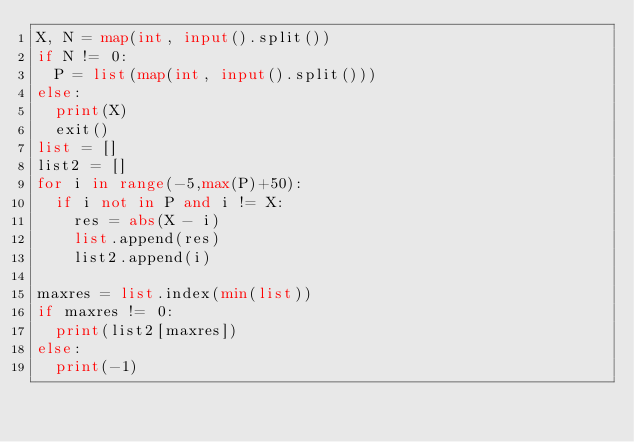Convert code to text. <code><loc_0><loc_0><loc_500><loc_500><_Python_>X, N = map(int, input().split())
if N != 0:
  P = list(map(int, input().split()))
else:
  print(X)
  exit()
list = []
list2 = []
for i in range(-5,max(P)+50):
  if i not in P and i != X:
    res = abs(X - i)
    list.append(res)
    list2.append(i)
    
maxres = list.index(min(list))
if maxres != 0:
  print(list2[maxres])
else:
  print(-1)
</code> 